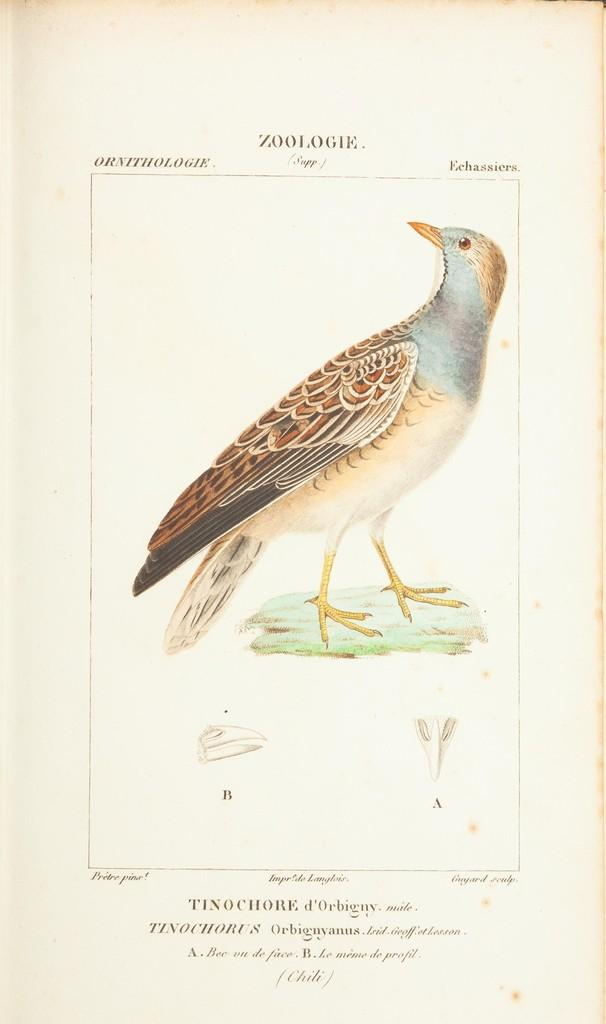What type of visual is the image? The image is a poster. What is depicted in the poster? There is a depiction of a bird in the image. Where is the bird located in the image? The bird is standing on the grass. Is there any text present on the image? Yes, there is text on the image. How many houses can be seen in the image? There are no houses depicted in the image; it features a bird standing on the grass. What type of bell is hanging from the bird's neck in the image? There is no bell present in the image, as it only features a bird standing on the grass and text on the poster. 